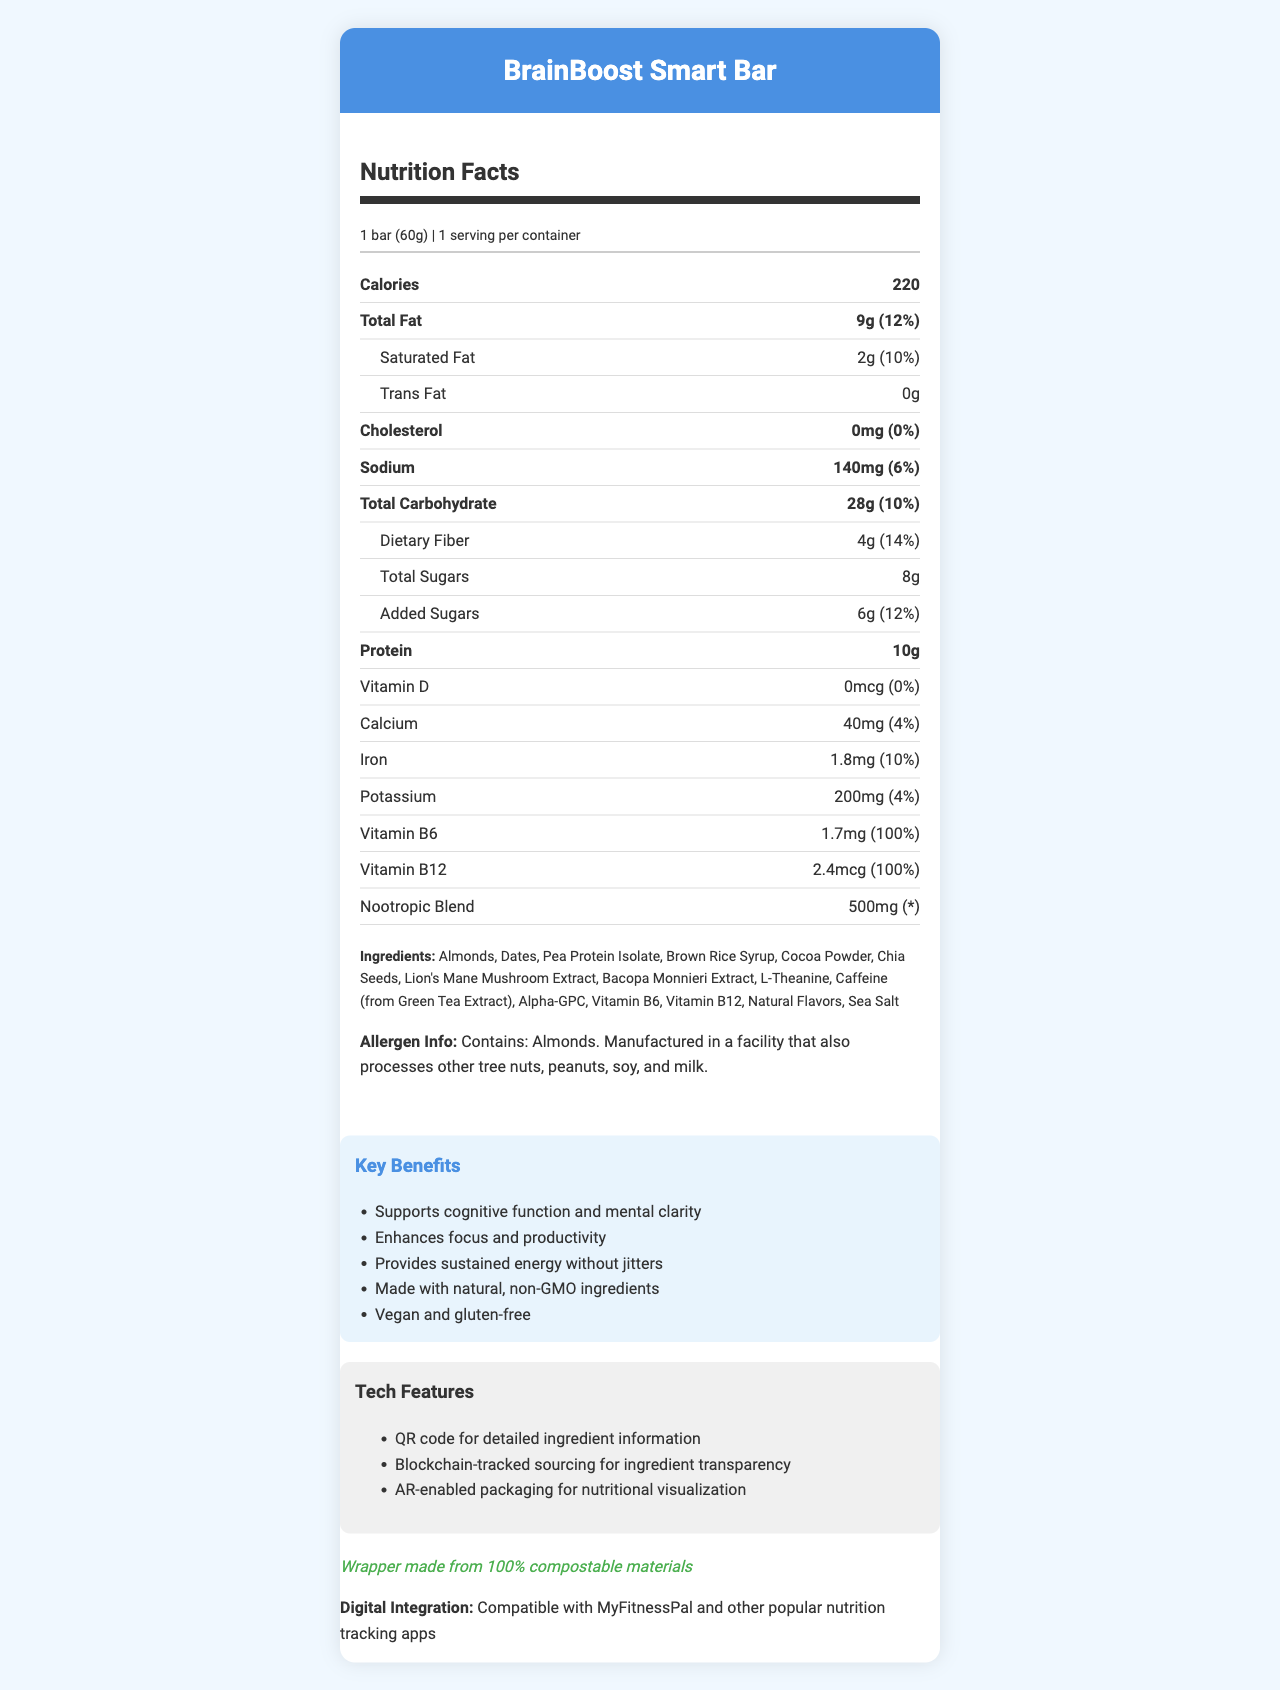what is the serving size of the BrainBoost Smart Bar? The serving size is mentioned at the top of the Nutrition Facts section as "1 bar (60g)".
Answer: 1 bar (60g) how many calories are in one serving of the BrainBoost Smart Bar? The number of calories is listed as "220" in bold under the Nutrition Facts heading.
Answer: 220 how much protein is in one serving? The protein content is listed in the Nutrition Facts section as "10g".
Answer: 10g what is the daily value percentage of dietary fiber? The daily value percentage for dietary fiber is listed as "14%" next to "Dietary Fiber".
Answer: 14% what is the amount of iron in each serving? The iron content is listed as "1.8mg" under the Nutrition Facts section.
Answer: 1.8mg which ingredient in the BrainBoost Smart Bar is used as a source of protein? A. Almonds B. Pea Protein Isolate C. Cocoa Powder D. Chia Seeds The ingredient list includes "Pea Protein Isolate," which is a common source of protein.
Answer: B what is the amount of total sugars in the BrainBoost Smart Bar? A. 4g B. 6g C. 8g D. 10g The total sugars amount is listed as "8g" under the Nutrition Facts section.
Answer: C how much sodium is in one serving of the BrainBoost Smart Bar? The sodium content is listed as "140mg" under the Nutrition Facts section.
Answer: 140mg does the BrainBoost Smart Bar contain any cholesterol? The cholesterol amount is listed as "0mg," which indicates it contains no cholesterol.
Answer: No does the BrainBoost Smart Bar contain any trans fat? The trans fat content is listed as "0g," which indicates there is no trans fat.
Answer: No what are the key benefits of the BrainBoost Smart Bar? The key benefits are listed in the claims section of the document.
Answer: Supports cognitive function and mental clarity, Enhances focus and productivity, Provides sustained energy without jitters, Made with natural, non-GMO ingredients, Vegan and gluten-free what are the tech features included with the BrainBoost Smart Bar? The tech features are listed in the corresponding section under "Tech Features".
Answer: QR code for detailed ingredient information, Blockchain-tracked sourcing for ingredient transparency, AR-enabled packaging for nutritional visualization can this product be used by individuals with peanut allergies? The allergen information states it contains almonds and is manufactured in a facility processing tree nuts, peanuts, soy, and milk, but does not specify cross-contamination levels.
Answer: Cannot be determined what is the daily value percentage of added sugars? The daily value percentage for added sugars is listed as "12%" under the Nutrition Facts section.
Answer: 12% summarize the main information provided by the BrainBoost Smart Bar's Nutrition Facts Label. The summary encapsulates the key nutritional information, ingredients, benefits, and additional features of the BrainBoost Smart Bar as described in the document.
Answer: The BrainBoost Smart Bar is a 60g snack bar designed to support cognitive function and enhance focus. It contains 220 calories per serving, with nutrients like 9g of total fat, 10g of protein, and 8g of sugars. Key ingredients include almonds, dates, and a nootropic blend. It offers tech features like QR codes for ingredient details, blockchain transparency, and AR-enabled packaging. It also promotes sustainability with compostable wrappers and is suitable for vegans and individuals avoiding gluten. 